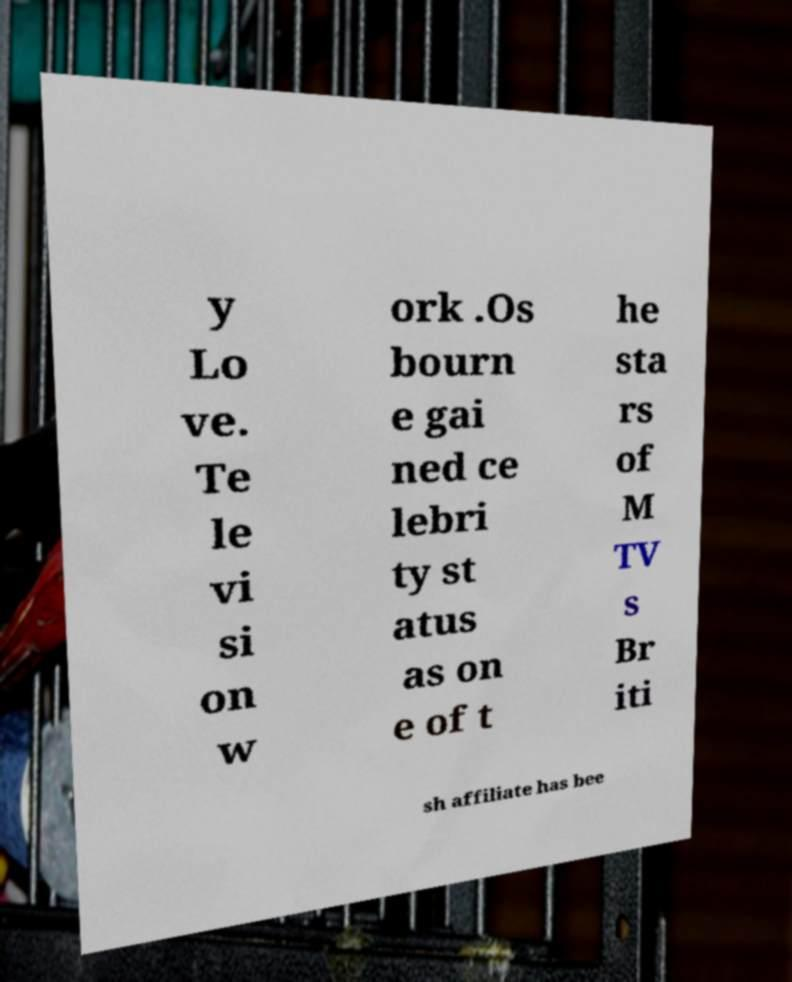Please identify and transcribe the text found in this image. y Lo ve. Te le vi si on w ork .Os bourn e gai ned ce lebri ty st atus as on e of t he sta rs of M TV s Br iti sh affiliate has bee 